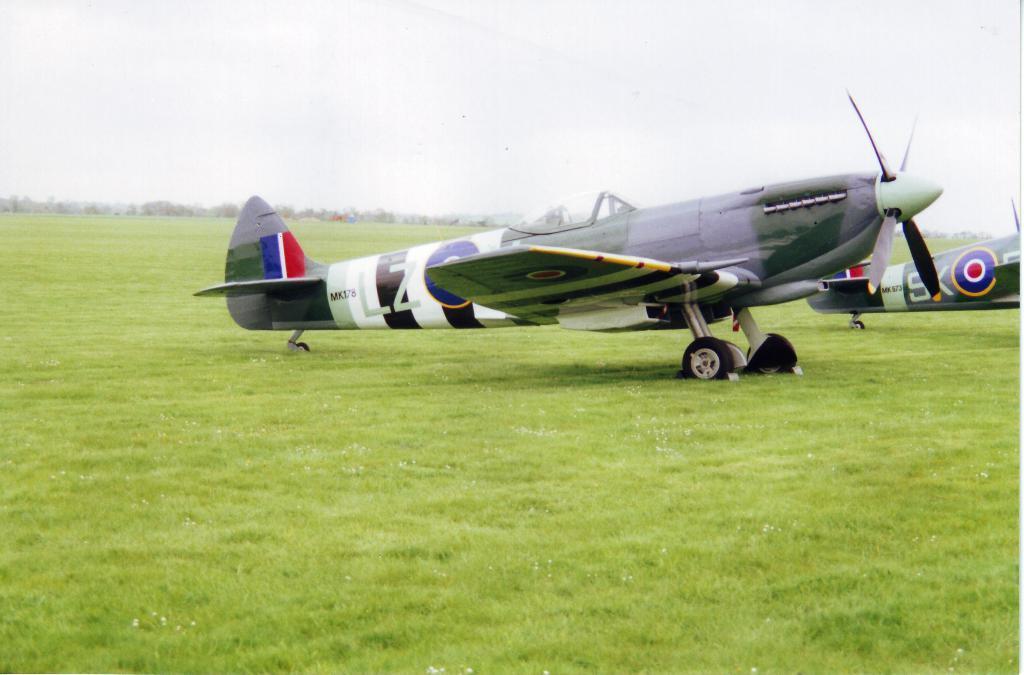In one or two sentences, can you explain what this image depicts? This image is taken outdoors. At the bottom of the image there is a ground with grass on it. At the top of the image there is the sky with clouds. In the background there are few trees. On the right side of the image there are two airplanes on the ground. 